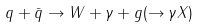Convert formula to latex. <formula><loc_0><loc_0><loc_500><loc_500>q + \bar { q } \rightarrow W + \gamma + g ( \rightarrow \gamma X )</formula> 